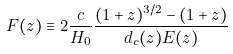<formula> <loc_0><loc_0><loc_500><loc_500>F ( z ) \equiv 2 \frac { c } { H _ { 0 } } \frac { ( 1 + z ) ^ { 3 / 2 } - ( 1 + z ) } { d _ { c } ( z ) E ( z ) }</formula> 